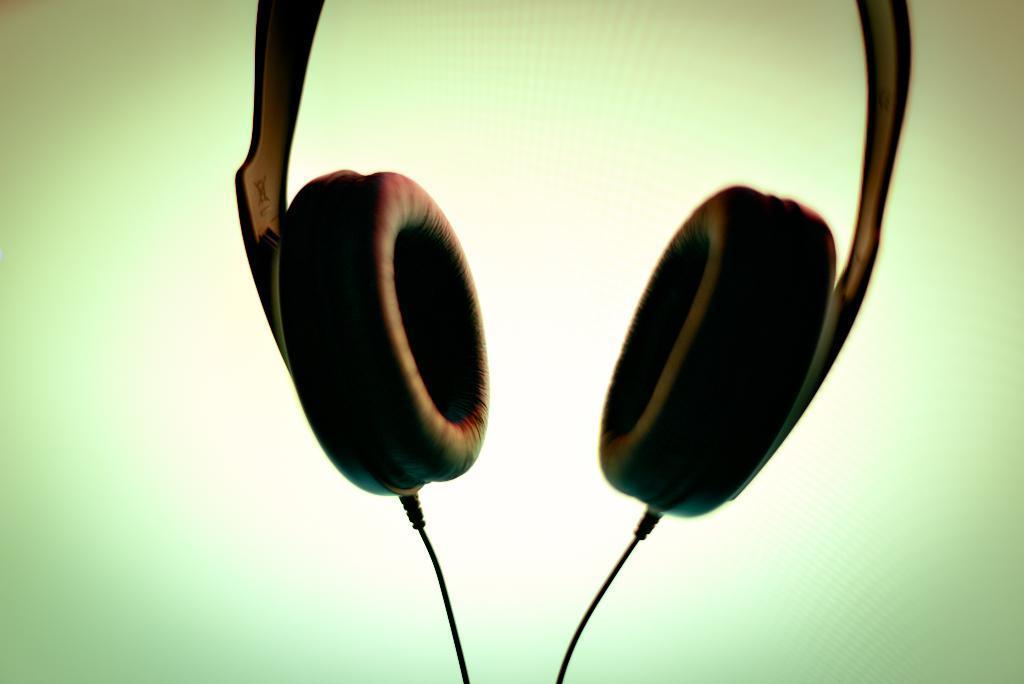Can you describe this image briefly? In the foreground of this image, there is a headset and two cables of it at the bottom with the green and cream background. 